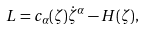Convert formula to latex. <formula><loc_0><loc_0><loc_500><loc_500>L = c _ { \alpha } ( \zeta ) { \dot { \zeta } ^ { \alpha } } - H ( \zeta ) ,</formula> 